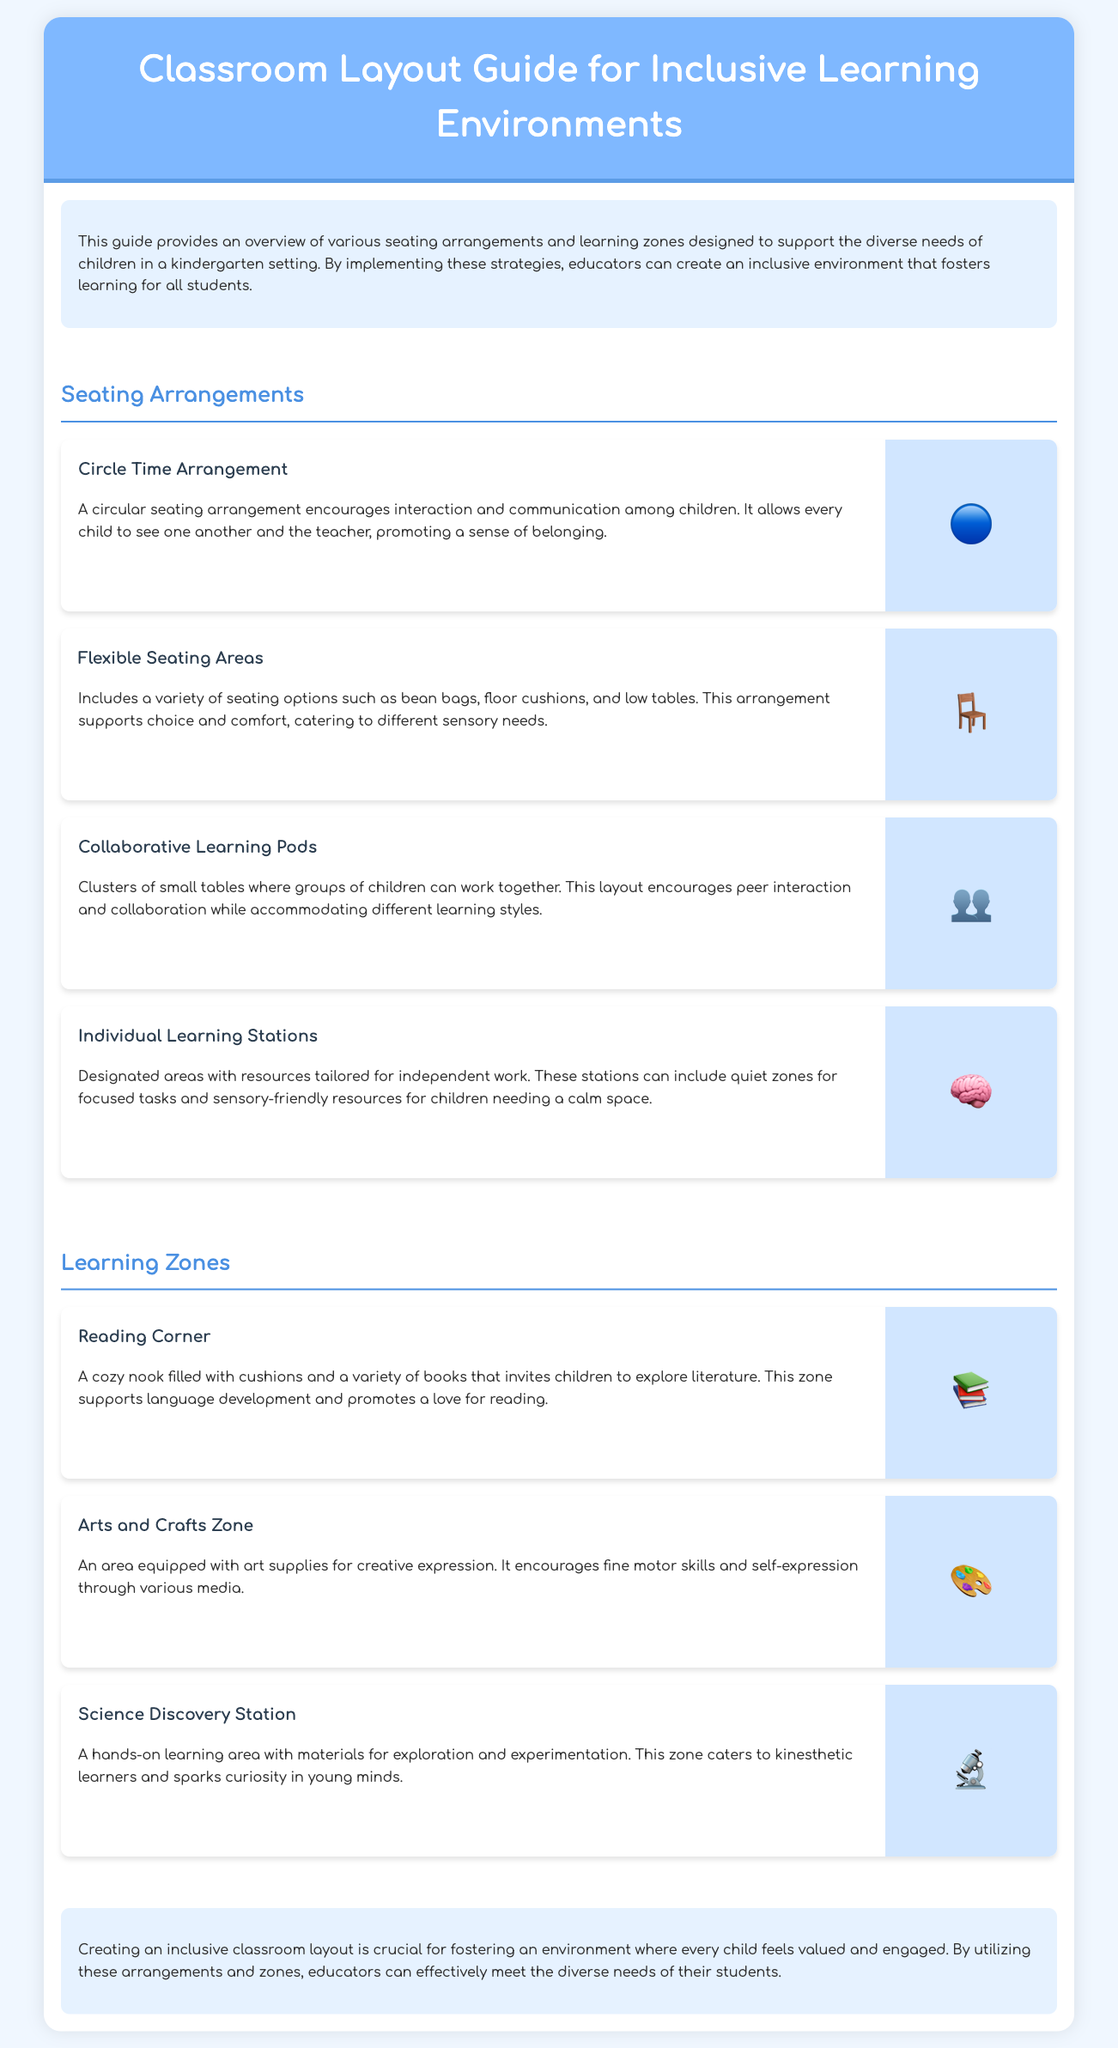What is the purpose of the guide? The guide provides an overview of various seating arrangements and learning zones designed to support the diverse needs of children in a kindergarten setting.
Answer: Support diverse needs What seating arrangement encourages interaction among children? The document mentions a specific seating arrangement that promotes interaction and communication, allowing every child to see one another.
Answer: Circle Time Arrangement What is included in the flexible seating areas? The flexible seating areas contain a variety of seating options aimed at accommodating different sensory needs.
Answer: Bean bags, floor cushions, and low tables What is the focus of the reading corner? The reading corner is designed to foster a particular area of child development and interests.
Answer: Language development What type of learning is catered to at the Science Discovery Station? The Science Discovery Station supports a specific learning style associated with hands-on activities and exploration.
Answer: Kinesthetic learners How many seating arrangements are discussed in the document? The guide lists the different seating arrangements available for inclusive learning environments.
Answer: Four What is the main goal of creating an inclusive classroom layout? The conclusion of the document summarizes the importance of a specific concept in the learning environment.
Answer: Fostering an environment where every child feels valued What does the Arts and Crafts Zone promote? The document specifies the skills and forms of expression encouraged within this learning zone.
Answer: Fine motor skills and self-expression 